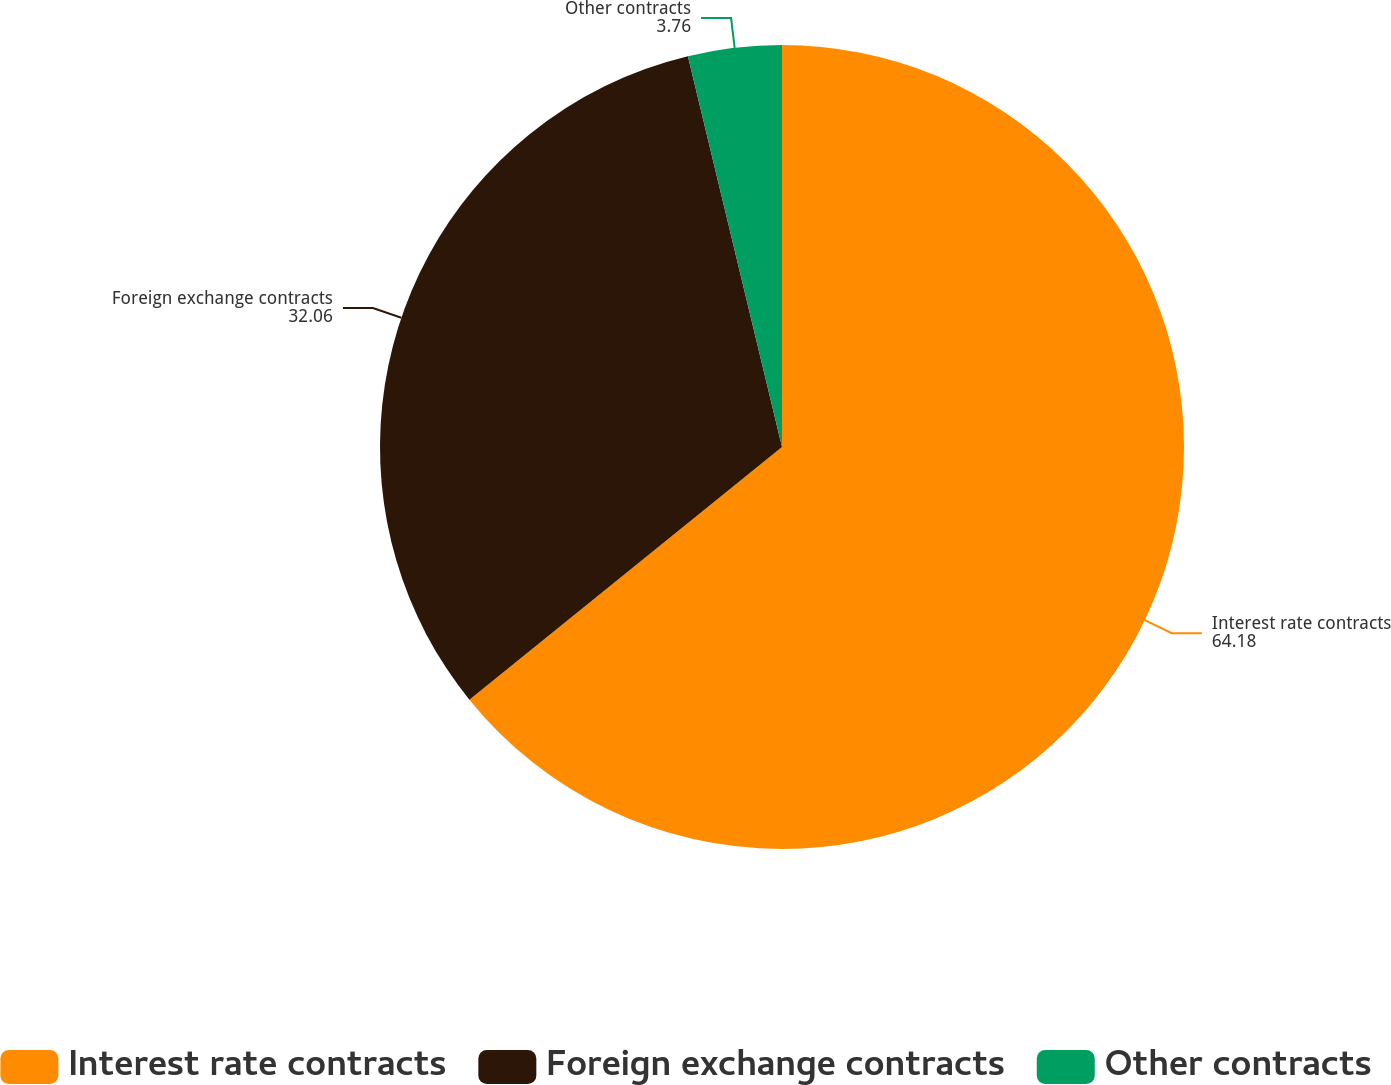Convert chart. <chart><loc_0><loc_0><loc_500><loc_500><pie_chart><fcel>Interest rate contracts<fcel>Foreign exchange contracts<fcel>Other contracts<nl><fcel>64.18%<fcel>32.06%<fcel>3.76%<nl></chart> 